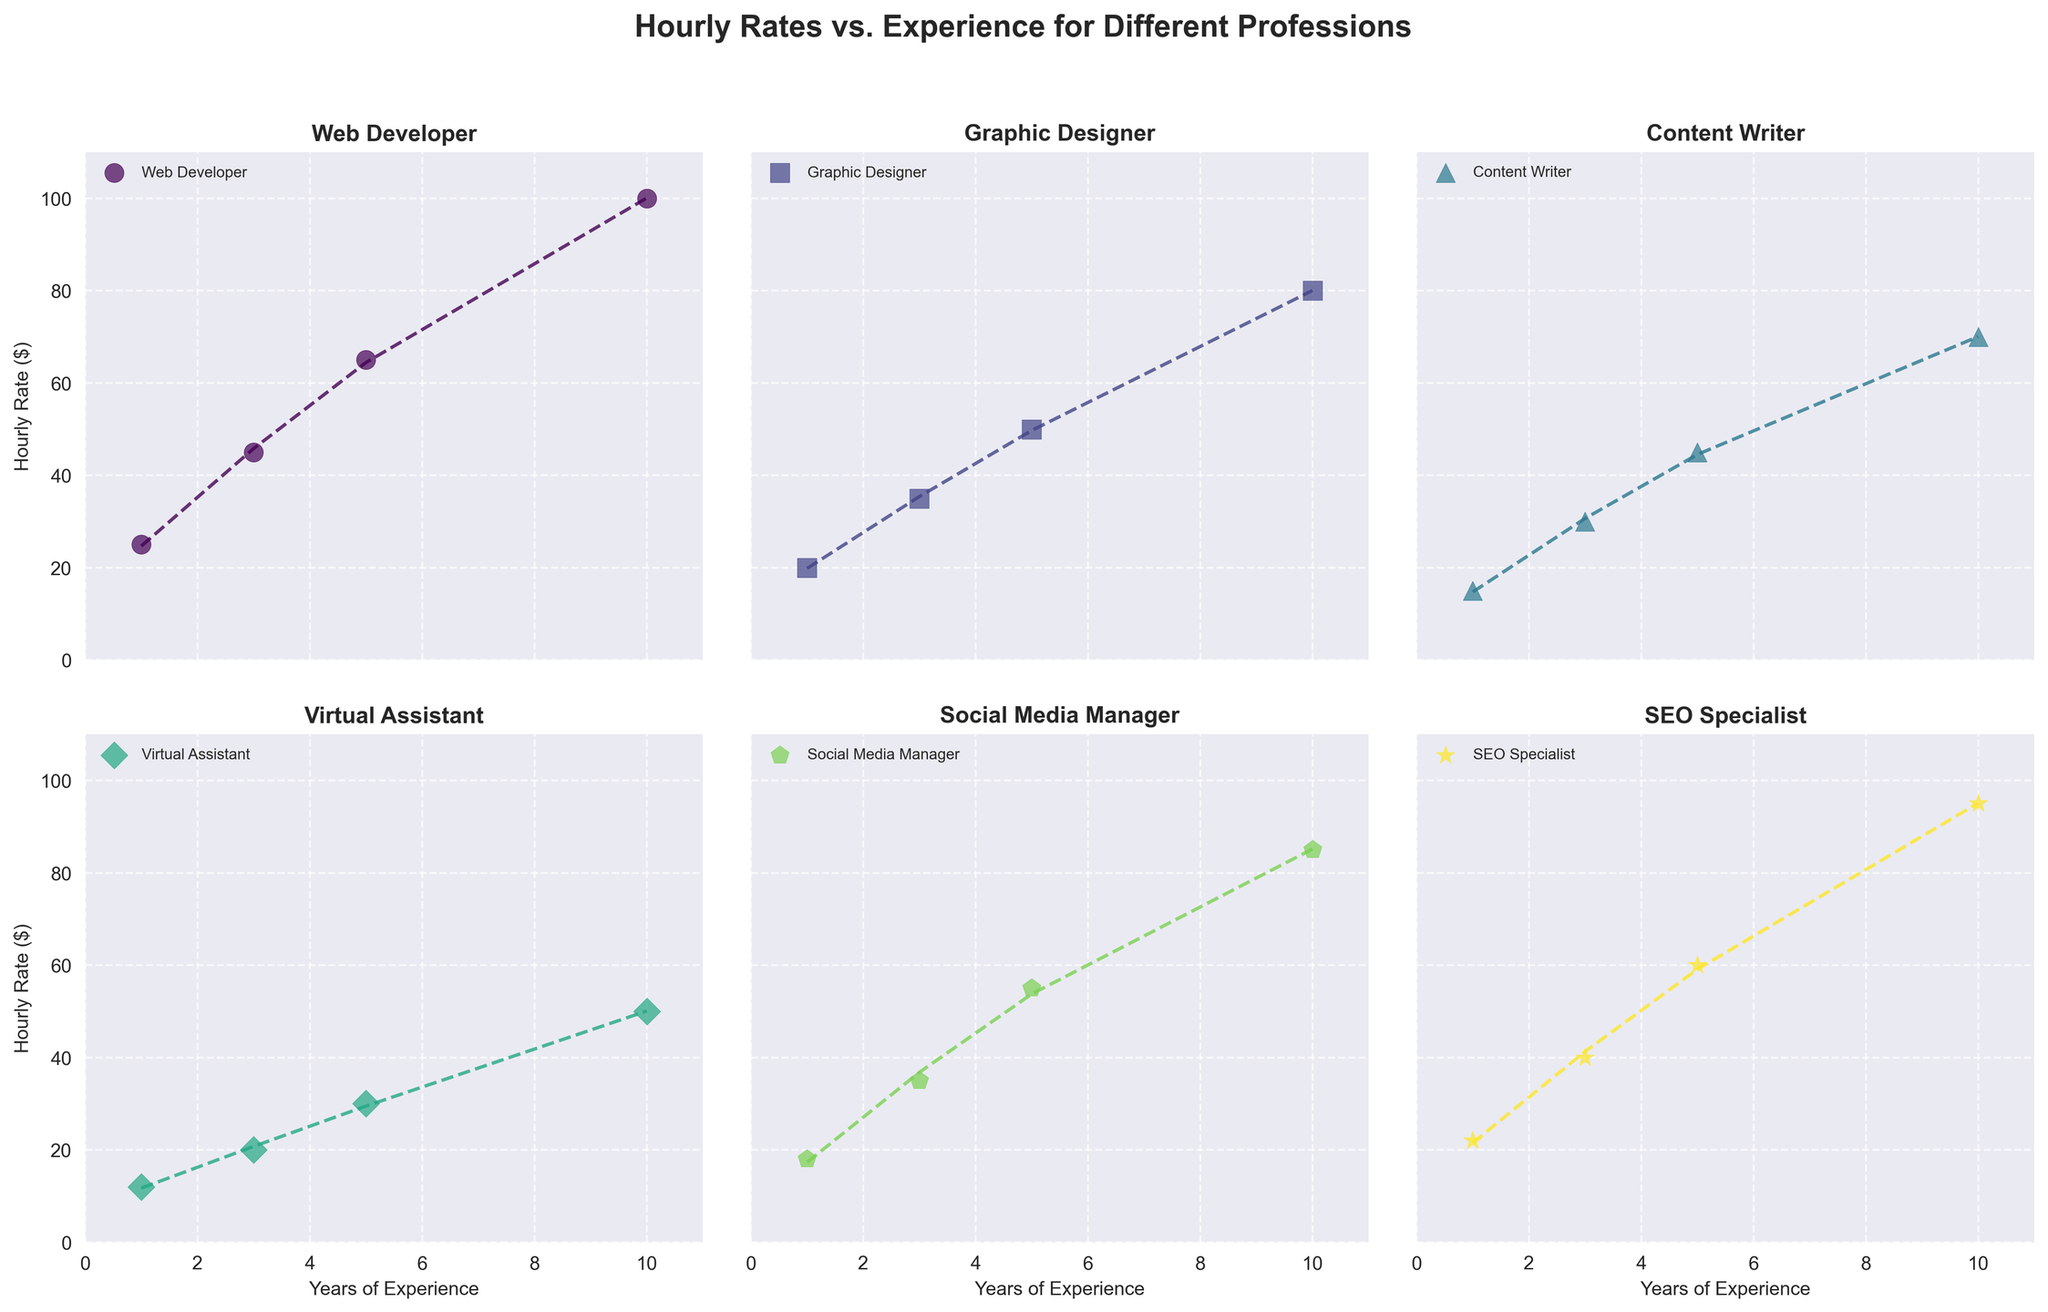What is the title of the figure? The title of the figure is displayed at the top center of the subplot. It summarizes the content of the entire figure.
Answer: Hourly Rates vs. Experience for Different Professions Which profession has the highest hourly rate for 10 years of experience? By looking at all the subplots and the points corresponding to 10 years of experience on the x-axis, the highest y-value (hourly rate) can be identified.
Answer: Web Developer Are there any professions with an hourly rate above $100? By scanning all the subplots' y-axis values, we look for any outliers or data points above the $100 mark.
Answer: No What is the range of hourly rates for a Content Writer? To find the range, we look for the minimum and maximum data points in the Content Writer subplot. The minimum is for 1 year of experience, and the maximum is for 10 years of experience.
Answer: $15 to $70 Which profession sees the greatest increase in hourly rate from 5 years to 10 years of experience? By comparing the data points for 5 years and 10 years of experience in each subplot, we calculate the difference and identify the largest increase.
Answer: Web Developer How do Virtual Assistants' hourly rates compare to Social Media Managers' hourly rates for 3 years of experience? Locate the data points for 3 years of experience for both Virtual Assistants and Social Media Managers in their respective subplots, and compare their y-values (hourly rates).
Answer: Social Media Managers have higher hourly rates What is the average hourly rate of all professions at 5 years of experience? Find the 5-year data point in each subplot and sum up the hourly rates, then divide by the number of professions (6).
Answer: $51 Which profession has the steepest regression line slope? Analyze the fitted polynomial regression lines in each subplot, and estimate which one appears to rise the fastest.
Answer: Web Developer Do Virtual Assistants and Graphic Designers show a similar trend in hourly rate increase with experience? Compare the shapes and slopes of the regression lines and data point trends in the Virtual Assistant and Graphic Designer subplots.
Answer: Yes What profession has the lowest starting hourly rate at 1 year of experience? Identify the data point for 1 year of experience in each subplot and find the lowest y-value (hourly rate).
Answer: Virtual Assistant 